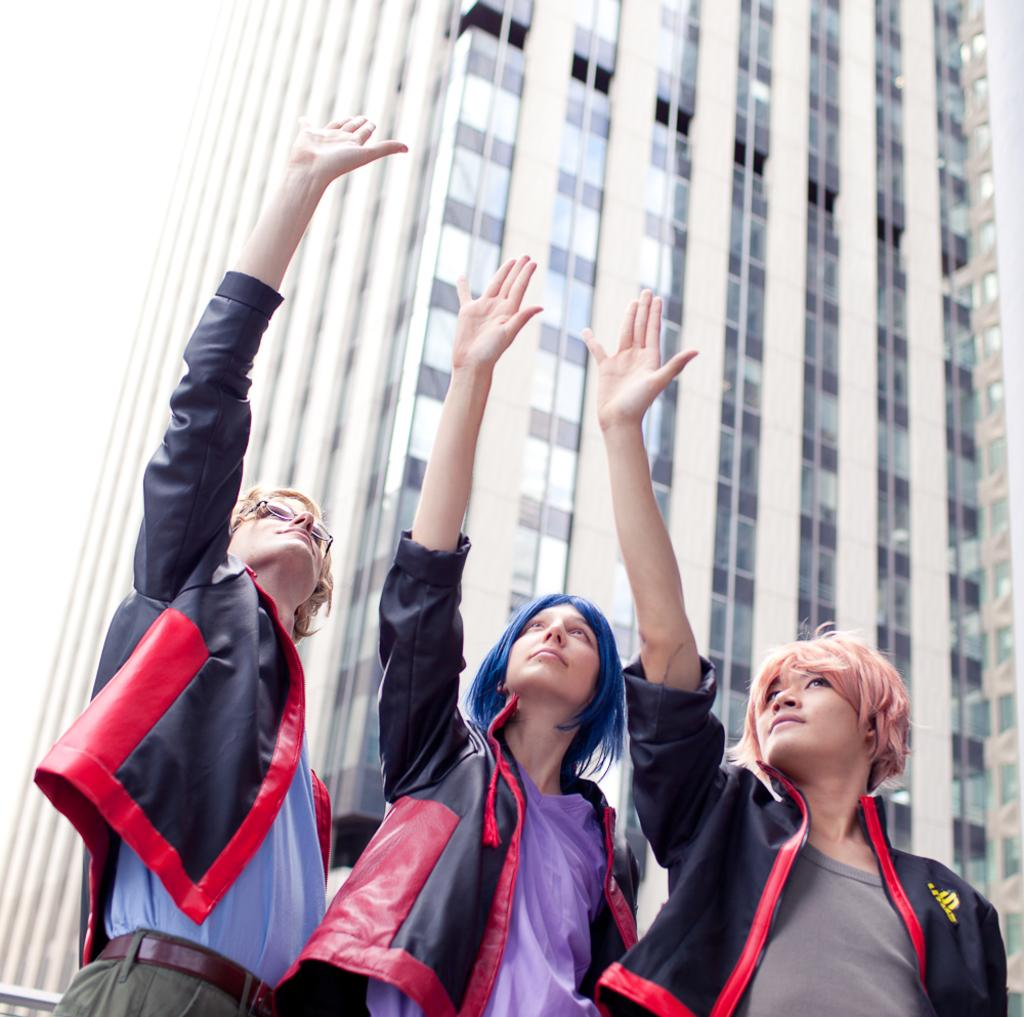How many people are visible in the image? There are three people standing in the image. What are the people doing with their hands? The people are raising their hands in the image. What can be seen in the background of the image? There is a building in the background of the image. What type of rain is falling on the committee in the downtown area of the image? There is no mention of rain, a committee, or a downtown area in the image. The image only shows three people raising their hands with a building in the background. 